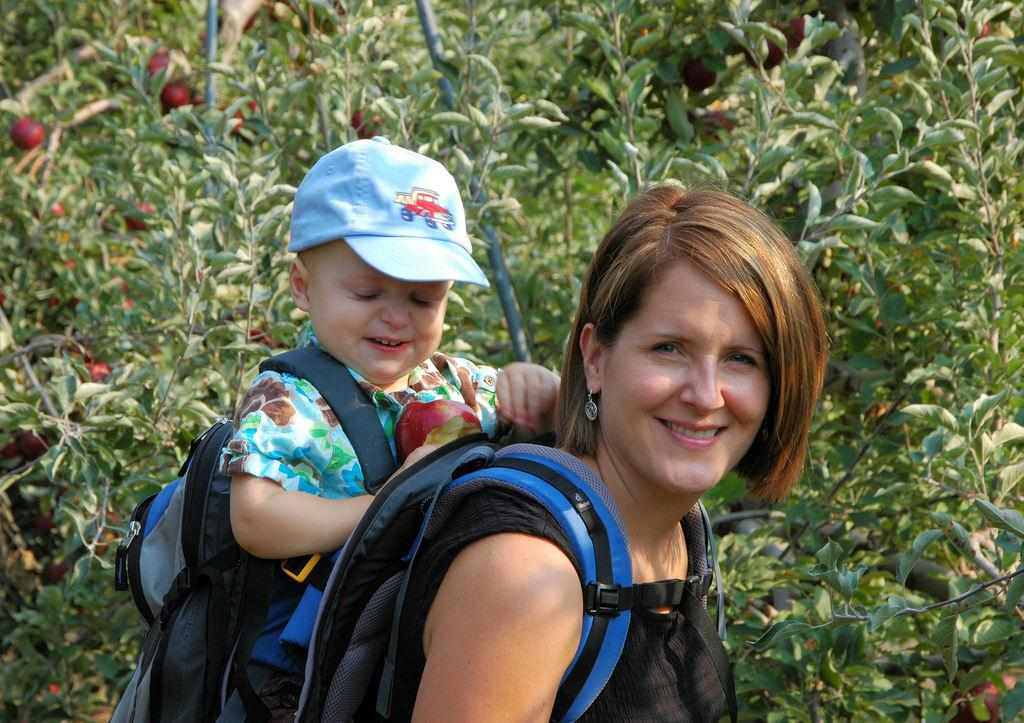Who or what is present in the image? There are people in the image. What are the people doing in the image? The people are carrying bags on their back. What else can be seen in the image besides the people? There are fruits and flowers in the image. Can you describe the flowers in the image? The flowers are on a plant. What type of skin can be seen on the people in the image? There is no information about the skin of the people in the image, so it cannot be determined. Can you tell me how many sea creatures are present in the image? There are no sea creatures present in the image; it features people carrying bags, fruits, and flowers. 